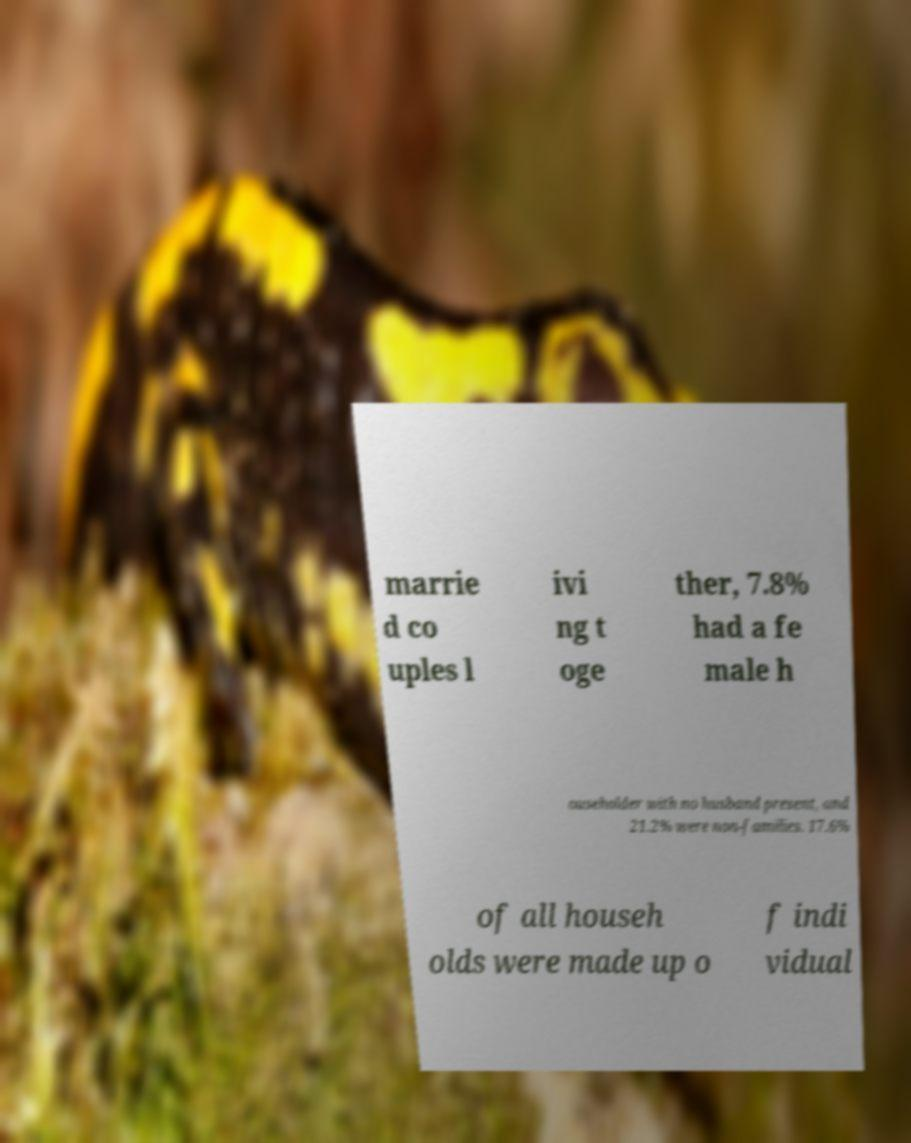Please read and relay the text visible in this image. What does it say? marrie d co uples l ivi ng t oge ther, 7.8% had a fe male h ouseholder with no husband present, and 21.2% were non-families. 17.6% of all househ olds were made up o f indi vidual 